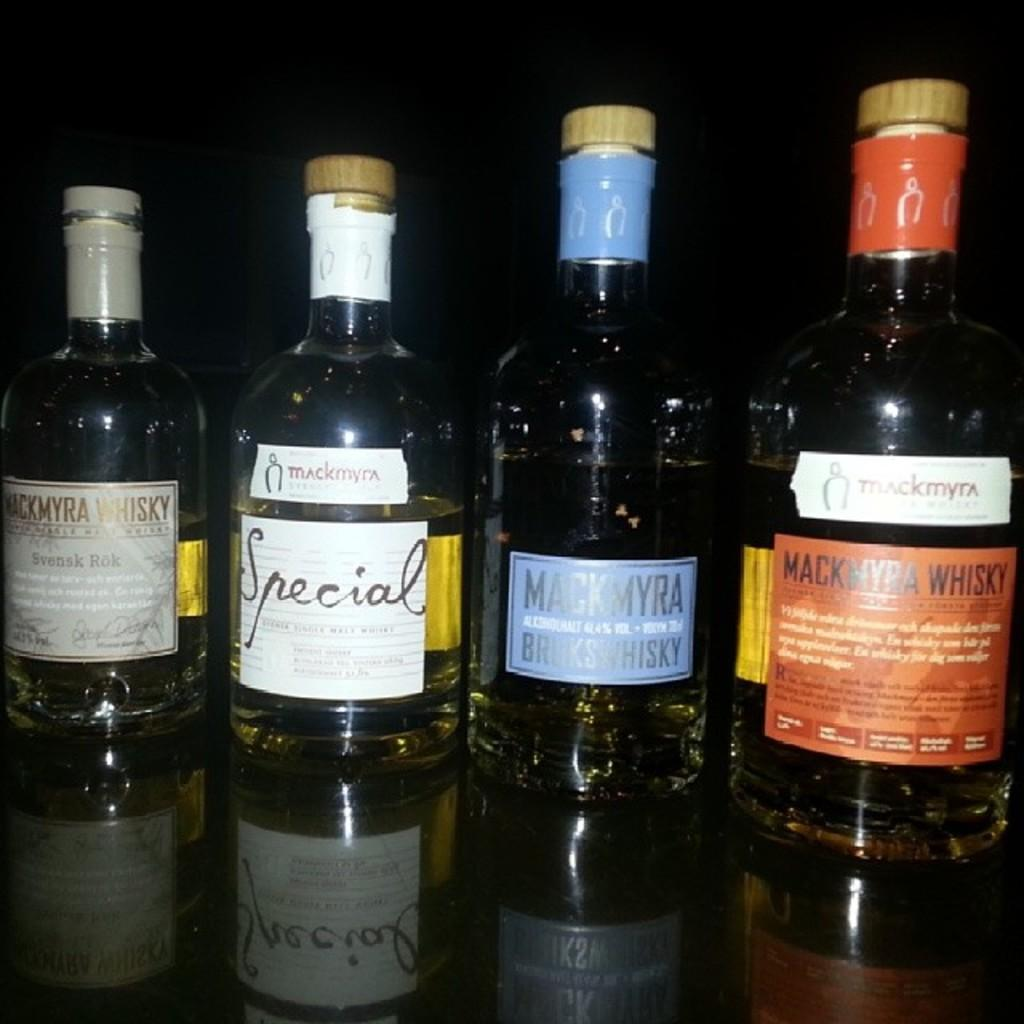<image>
Relay a brief, clear account of the picture shown. A few bottles of Special whiskey sit together on a table. 